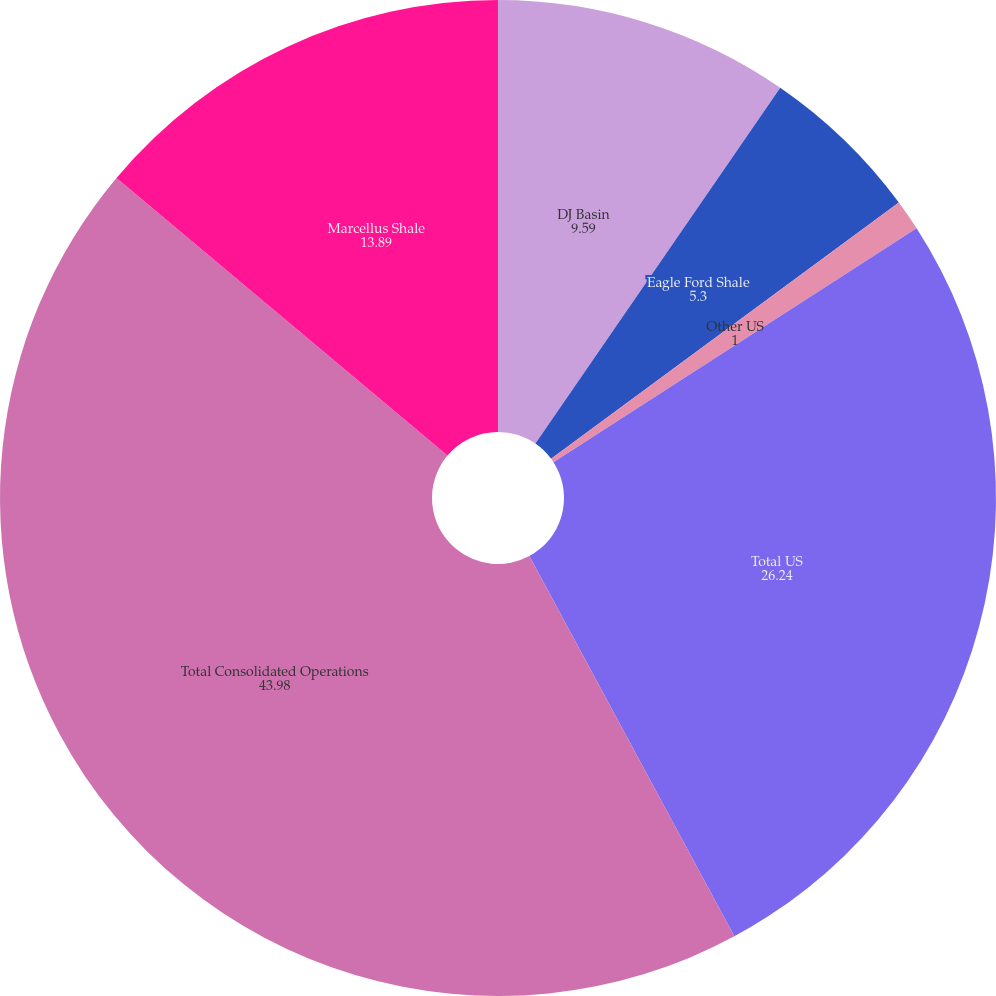Convert chart. <chart><loc_0><loc_0><loc_500><loc_500><pie_chart><fcel>DJ Basin<fcel>Eagle Ford Shale<fcel>Other US<fcel>Total US<fcel>Total Consolidated Operations<fcel>Marcellus Shale<nl><fcel>9.59%<fcel>5.3%<fcel>1.0%<fcel>26.24%<fcel>43.98%<fcel>13.89%<nl></chart> 